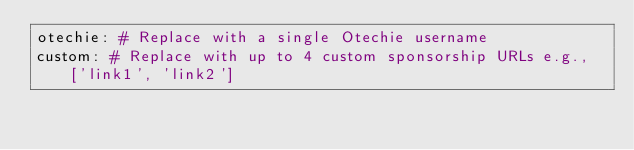<code> <loc_0><loc_0><loc_500><loc_500><_YAML_>otechie: # Replace with a single Otechie username
custom: # Replace with up to 4 custom sponsorship URLs e.g., ['link1', 'link2']
</code> 